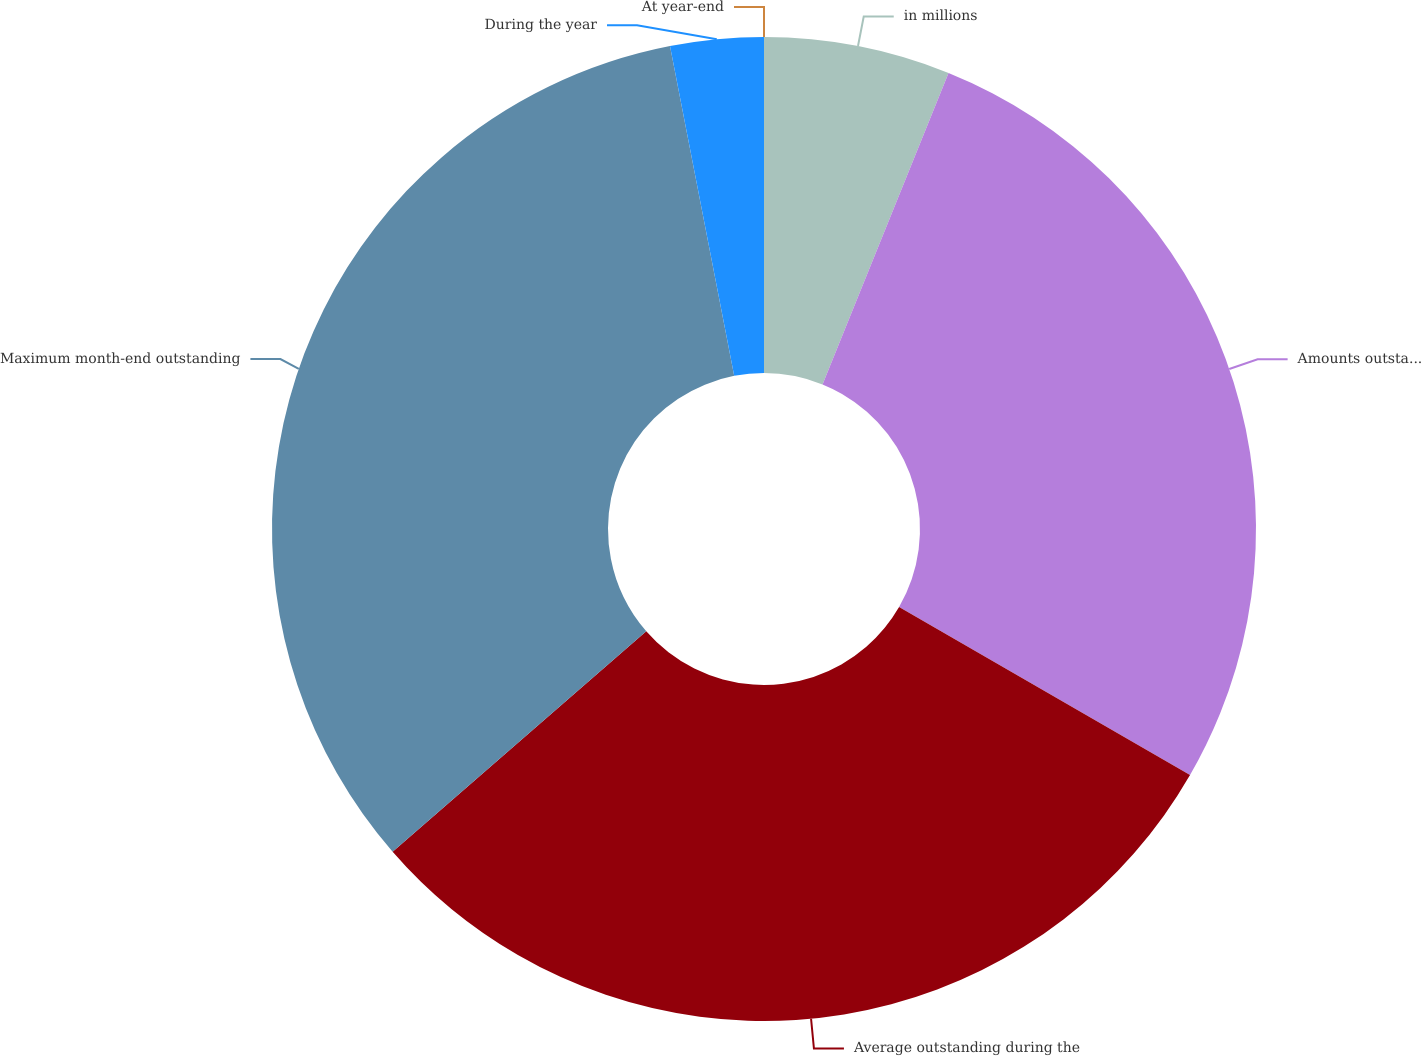Convert chart to OTSL. <chart><loc_0><loc_0><loc_500><loc_500><pie_chart><fcel>in millions<fcel>Amounts outstanding at<fcel>Average outstanding during the<fcel>Maximum month-end outstanding<fcel>During the year<fcel>At year-end<nl><fcel>6.12%<fcel>27.22%<fcel>30.28%<fcel>33.33%<fcel>3.06%<fcel>0.0%<nl></chart> 